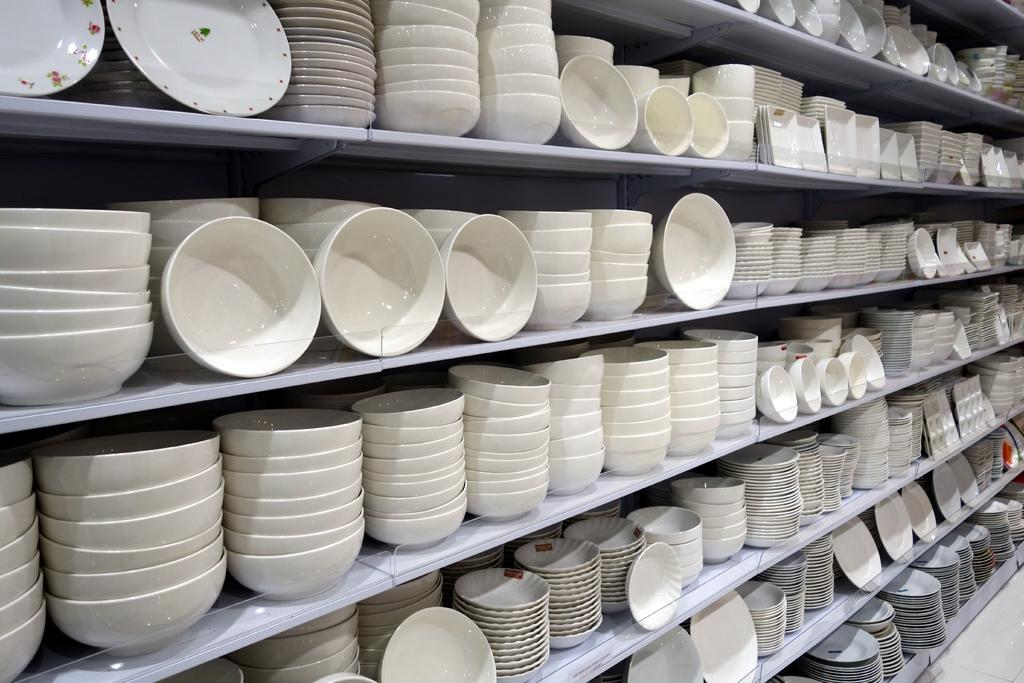What type of dishware is visible in the image? There are bowls, plates, and saucers in the image. How are the bowls, plates, and saucers arranged in the image? They are placed on racks. What can be seen in the background of the image? There is a wall in the background of the image. What part of the room is visible on the right side of the image? There is a floor visible on the right side of the image. What type of turkey is being served on the plates in the image? There are no turkeys or any food items visible on the plates in the image; only the bowls, plates, and saucers are present. What type of sponge is used to clean the dishes in the image? There is no sponge visible in the image, and the cleaning method for the dishes is not mentioned. 